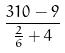Convert formula to latex. <formula><loc_0><loc_0><loc_500><loc_500>\frac { 3 1 0 - 9 } { \frac { 2 } { 6 } + 4 }</formula> 